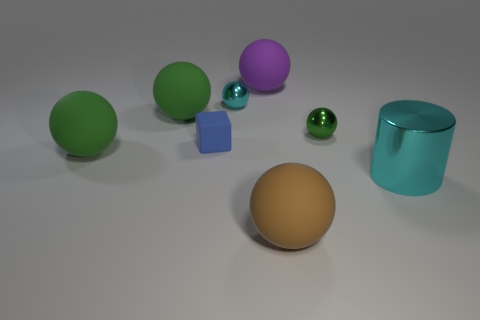How many green balls must be subtracted to get 1 green balls? 2 Subtract all green cylinders. How many green balls are left? 3 Subtract all purple balls. How many balls are left? 5 Subtract all brown balls. How many balls are left? 5 Subtract all blue balls. Subtract all blue cubes. How many balls are left? 6 Add 1 brown rubber spheres. How many objects exist? 9 Subtract all cubes. How many objects are left? 7 Subtract all cylinders. Subtract all green objects. How many objects are left? 4 Add 3 big matte balls. How many big matte balls are left? 7 Add 8 tiny red metallic cylinders. How many tiny red metallic cylinders exist? 8 